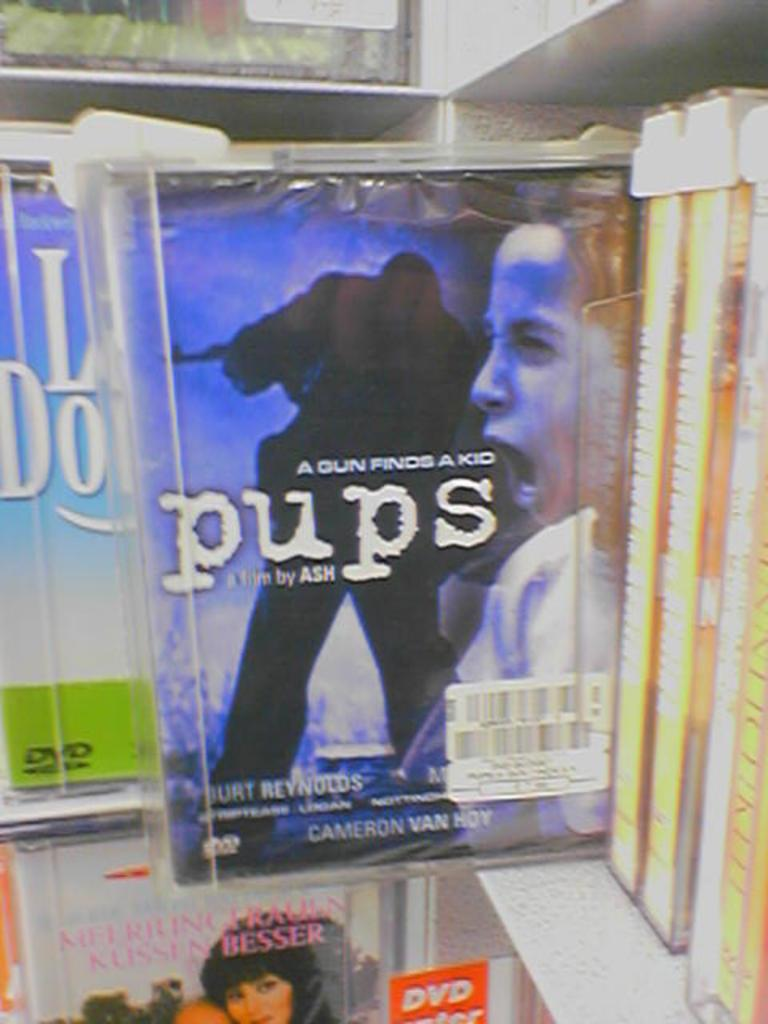<image>
Give a short and clear explanation of the subsequent image. display for dvd pups a film by ash starring burt reynolds 